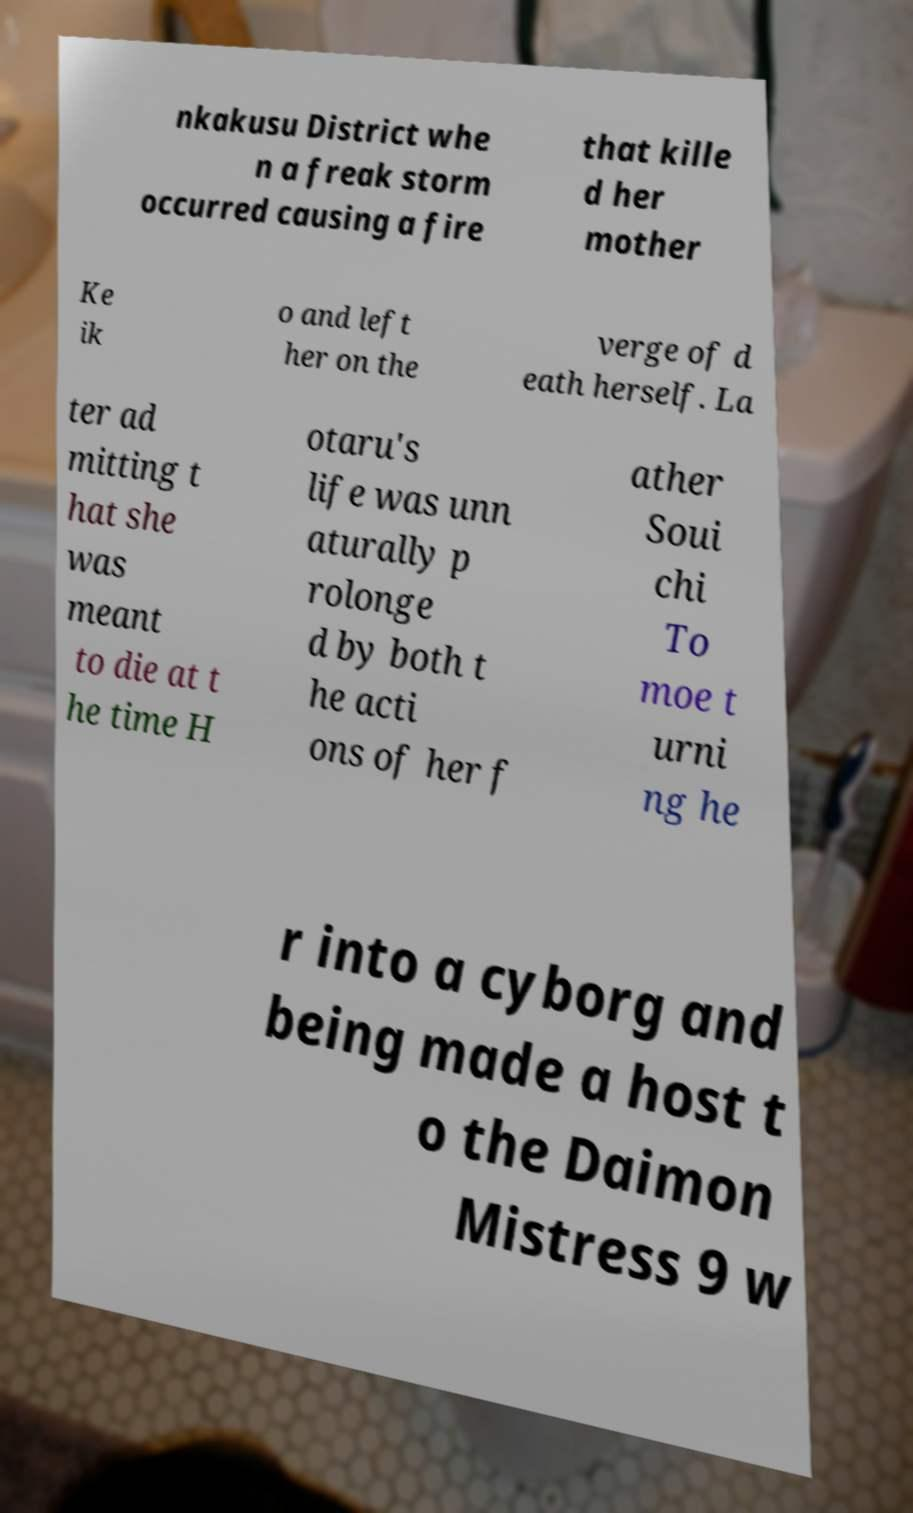Could you extract and type out the text from this image? nkakusu District whe n a freak storm occurred causing a fire that kille d her mother Ke ik o and left her on the verge of d eath herself. La ter ad mitting t hat she was meant to die at t he time H otaru's life was unn aturally p rolonge d by both t he acti ons of her f ather Soui chi To moe t urni ng he r into a cyborg and being made a host t o the Daimon Mistress 9 w 